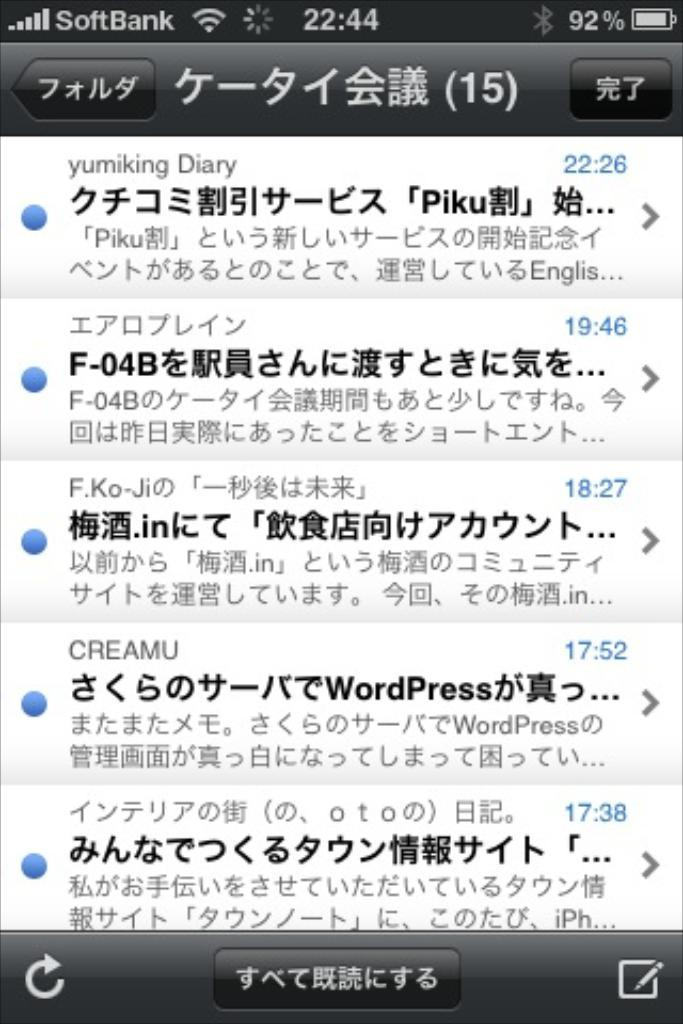<image>
Relay a brief, clear account of the picture shown. an iphone screen that says 'softbank' on the top left corner of it 